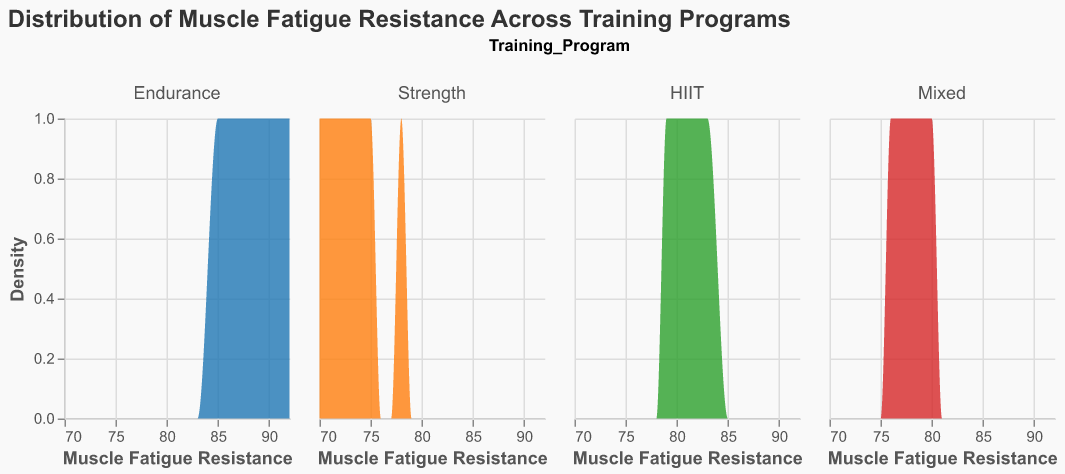What is the title of the figure? The title is usually at the top of the figure and it provides a concise description of what the plot is about. In this case, it’s displayed as "Distribution of Muscle Fatigue Resistance Across Training Programs."
Answer: Distribution of Muscle Fatigue Resistance Across Training Programs How many training programs are compared in this figure? The training programs are displayed as separate columns in the facet plot, representing different categories. You can count the number of distinct columns to find the number of training programs.
Answer: 4 What is the color used to represent the HIIT training program in the figure? One way to recognize this is by looking at the color scheme in the legend (although it is not provided here) or by identifying which of the density plots corresponds to the HIIT program based on the provided data and the usual layout of such plots. In this configuration, the color used for HIIT would be "#2ca02c."
Answer: Green Which training program has the highest muscle fatigue resistance value? By visually scanning the figure, observe which density plot extends the farthest to the right on the x-axis (Muscle Fatigue Resistance). The Endurance training program reaches up to 92 based on the data provided.
Answer: Endurance What is the general shape of the density plot for the Mixed training program compared to the Strength training program? By visually analyzing the figure, you can describe the density pattern for each training program. The Mixed program should have a narrower and possibly higher peak indicating more clustered values, while the Strength program shows a wider spread.
Answer: The Mixed program has a narrower peak What is the range of muscle fatigue resistance values for the Mixed training program? Examine the leftmost and rightmost positions of the Mixed training program's density plot. Based on the data, the muscle fatigue resistance values for Mixed range from 76 to 80.
Answer: 76-80 Which training program has the least overlap in muscle fatigue resistance with other programs? Look at how distinctly separate each density plot is without overlapping other plots. The Endurance training program likely has the least overlap as it’s concentrated at the higher end of the resistance spectrum.
Answer: Endurance What is the average muscle fatigue resistance for subjects in the HIIT program? First, list all the muscle fatigue resistance values for HIIT participants: 80, 83, 82, 79, 81. Summing these values gives 405. Dividing by the number of participants (5) gives the average: 405 / 5 = 81.
Answer: 81 Which training program shows the widest spread in muscle fatigue resistance values? Observe the width of the density plot for each training program across the x-axis. The Strength program, varying from 70 to 78, exhibits the widest spread compared to others.
Answer: Strength 